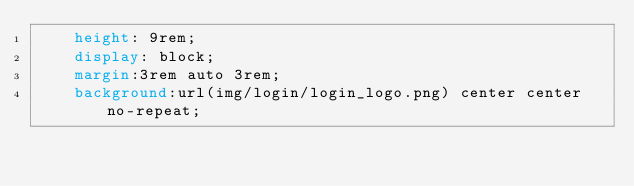Convert code to text. <code><loc_0><loc_0><loc_500><loc_500><_CSS_>	height: 9rem;
	display: block;
	margin:3rem auto 3rem;
	background:url(img/login/login_logo.png) center center no-repeat;</code> 